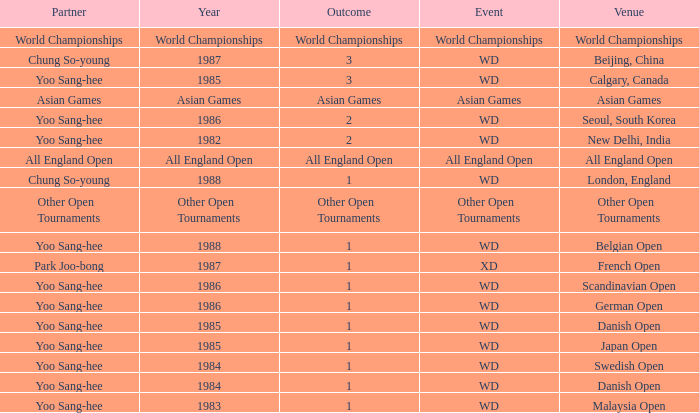What was the Outcome in 1983 of the WD Event? 1.0. 